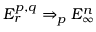<formula> <loc_0><loc_0><loc_500><loc_500>E _ { r } ^ { p , q } \Rightarrow _ { p } E _ { \infty } ^ { n }</formula> 